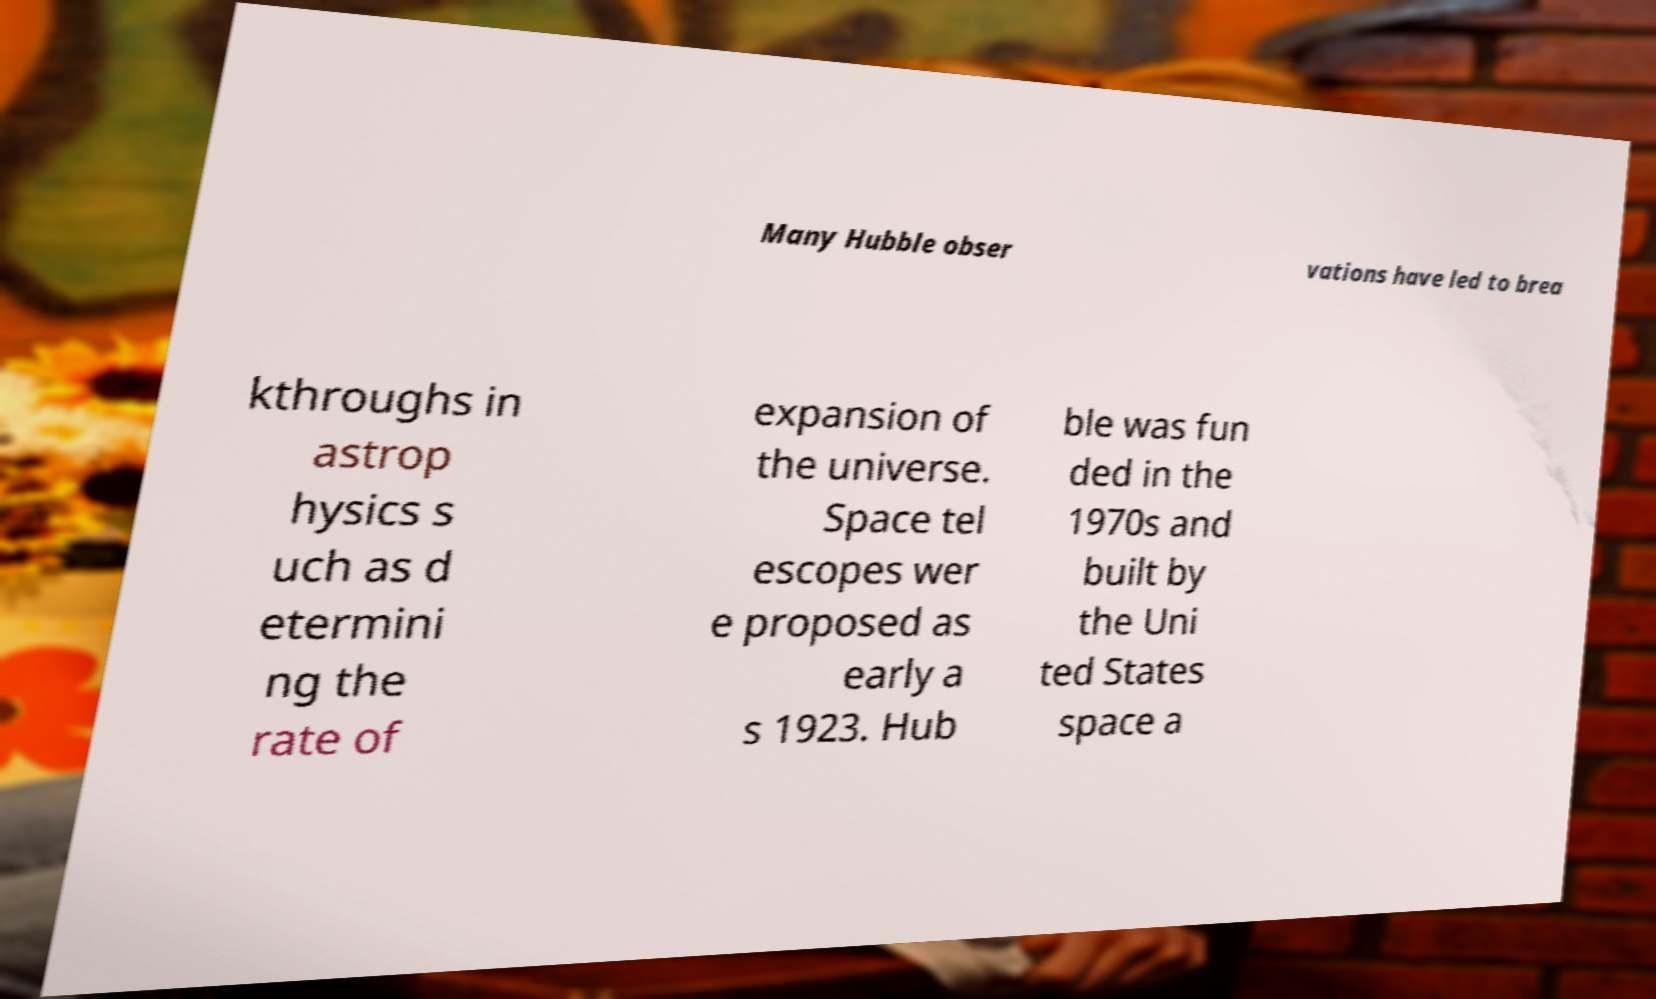Please read and relay the text visible in this image. What does it say? Many Hubble obser vations have led to brea kthroughs in astrop hysics s uch as d etermini ng the rate of expansion of the universe. Space tel escopes wer e proposed as early a s 1923. Hub ble was fun ded in the 1970s and built by the Uni ted States space a 